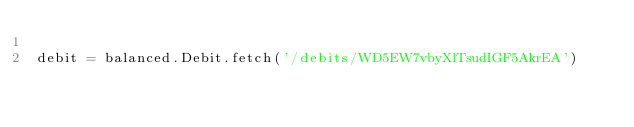<code> <loc_0><loc_0><loc_500><loc_500><_Python_>
debit = balanced.Debit.fetch('/debits/WD5EW7vbyXlTsudIGF5AkrEA')</code> 